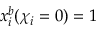<formula> <loc_0><loc_0><loc_500><loc_500>x _ { i } ^ { b } ( { \chi } _ { i } = 0 ) = 1</formula> 